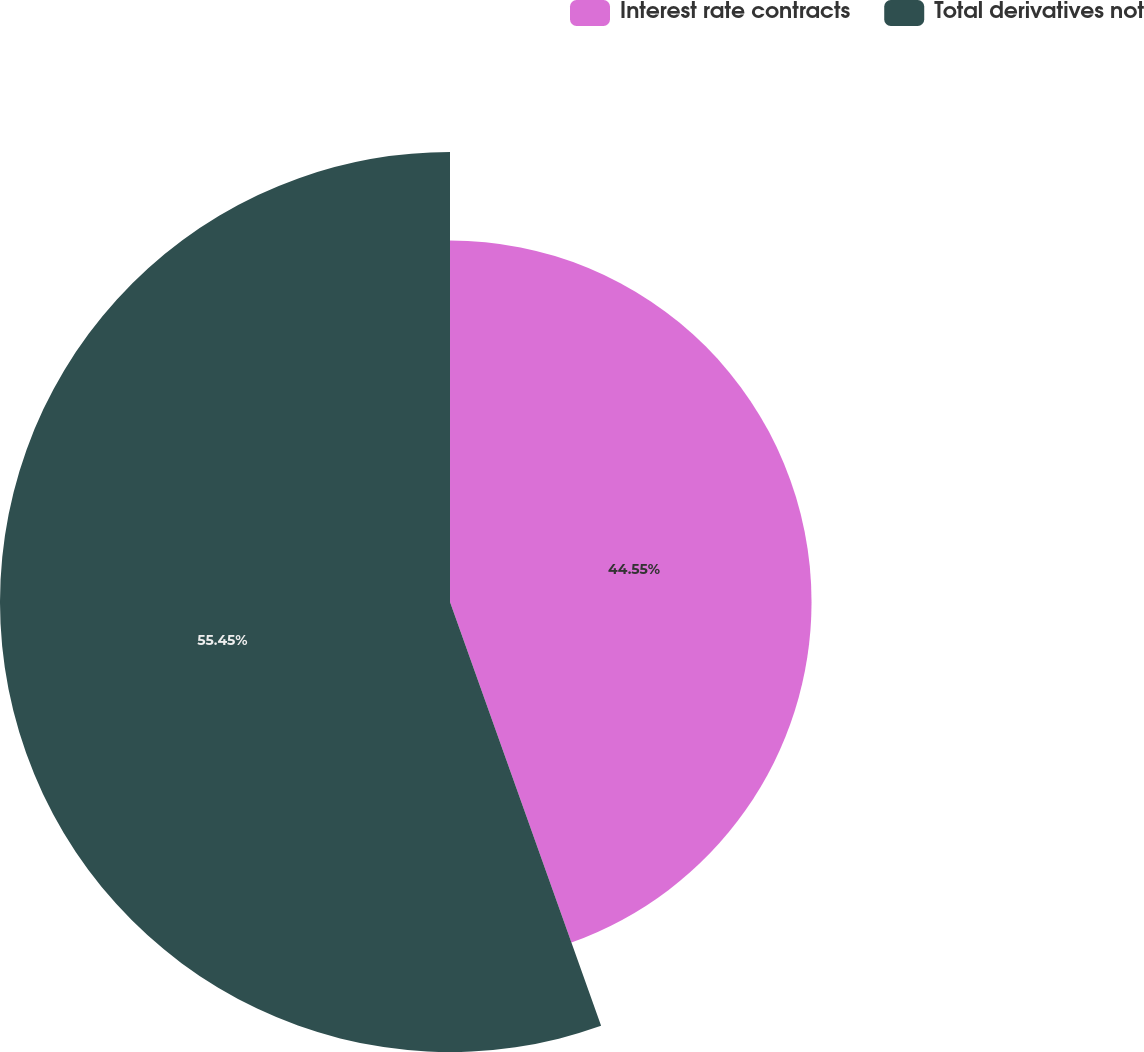<chart> <loc_0><loc_0><loc_500><loc_500><pie_chart><fcel>Interest rate contracts<fcel>Total derivatives not<nl><fcel>44.55%<fcel>55.45%<nl></chart> 